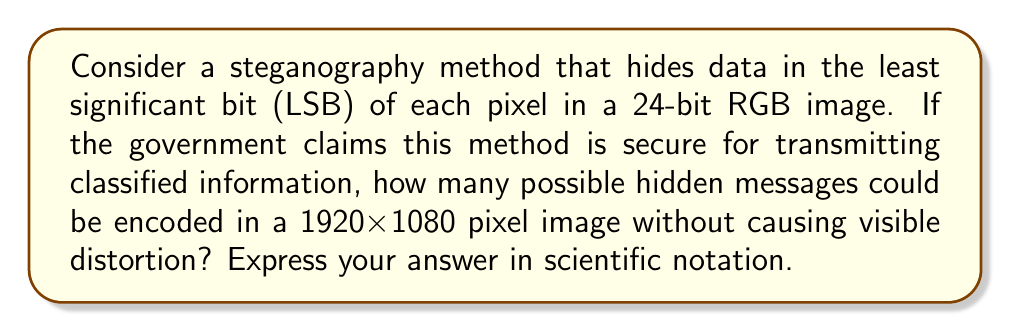Can you solve this math problem? Let's approach this step-by-step:

1) In a 24-bit RGB image, each pixel has 3 color channels (Red, Green, Blue), each with 8 bits.

2) We're using the LSB of each channel, so we have 3 bits per pixel to hide data.

3) The image size is 1920x1080 pixels.

4) Total number of pixels:
   $$ 1920 \times 1080 = 2,073,600 \text{ pixels} $$

5) Total number of bits available for hiding data:
   $$ 2,073,600 \times 3 = 6,220,800 \text{ bits} $$

6) Each bit can be either 0 or 1, so for each bit, there are 2 possibilities.

7) The total number of possible hidden messages is:
   $$ 2^{6,220,800} $$

8) This is an enormous number. To express it in scientific notation:
   $$ 2^{6,220,800} \approx 10^{1,873,251} $$

This calculation shows that an astronomical number of different messages could be hidden, raising questions about the government's claim of security. The sheer number of possibilities makes brute-force decryption infeasible, but it doesn't guarantee the method is unbreakable through other means.
Answer: $10^{1,873,251}$ 